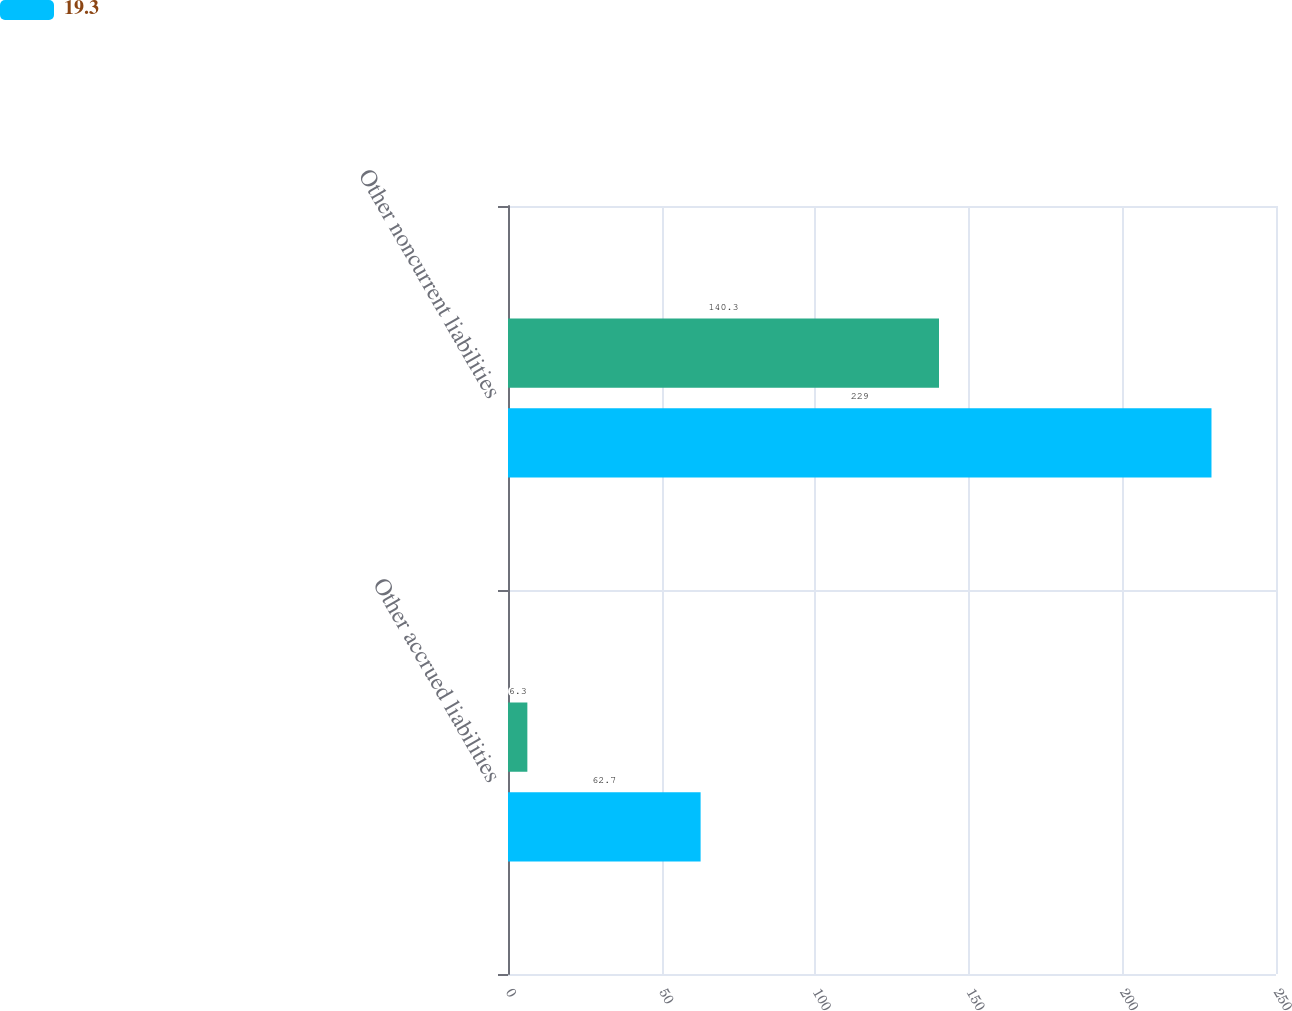Convert chart to OTSL. <chart><loc_0><loc_0><loc_500><loc_500><stacked_bar_chart><ecel><fcel>Other accrued liabilities<fcel>Other noncurrent liabilities<nl><fcel>nan<fcel>6.3<fcel>140.3<nl><fcel>19.3<fcel>62.7<fcel>229<nl></chart> 